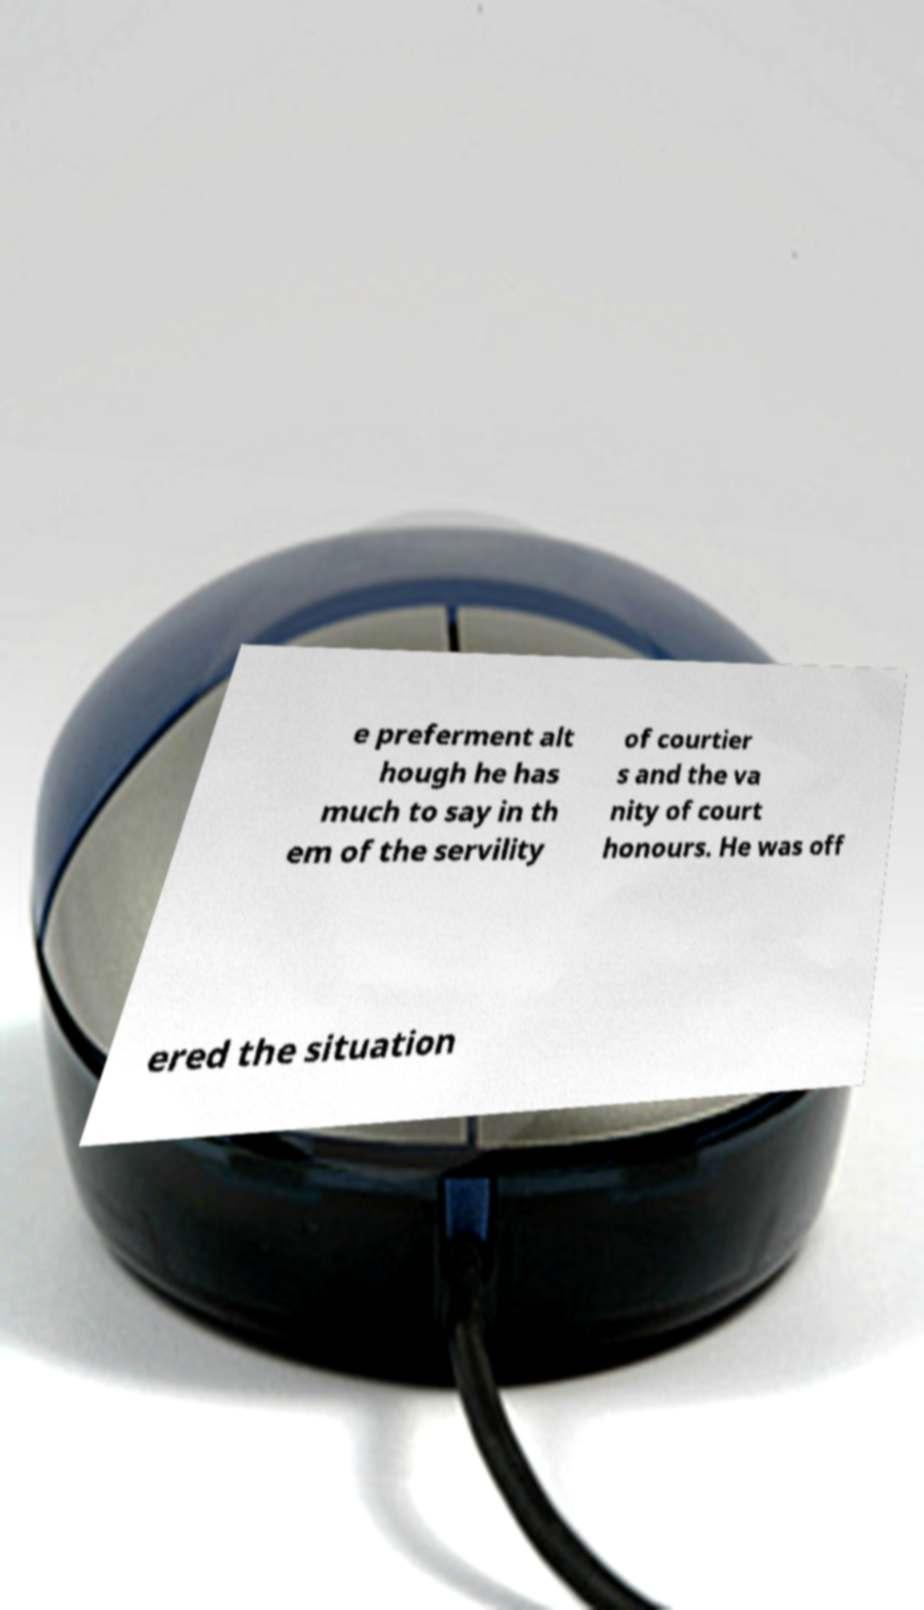What messages or text are displayed in this image? I need them in a readable, typed format. e preferment alt hough he has much to say in th em of the servility of courtier s and the va nity of court honours. He was off ered the situation 